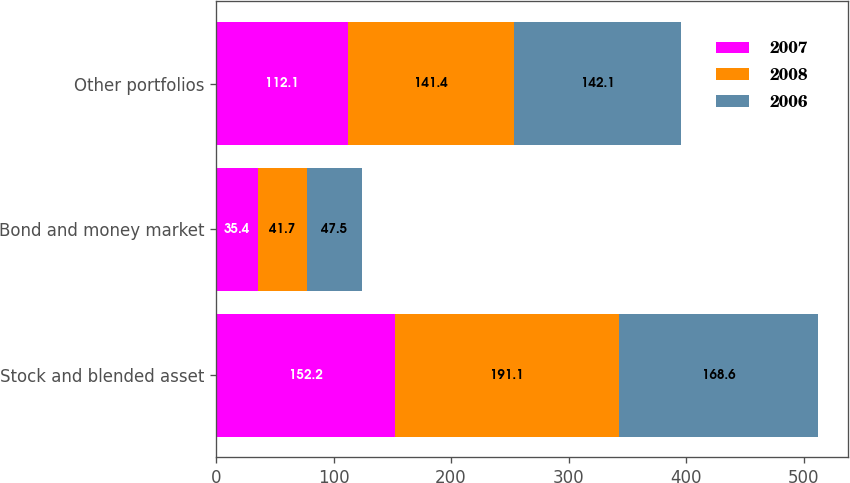<chart> <loc_0><loc_0><loc_500><loc_500><stacked_bar_chart><ecel><fcel>Stock and blended asset<fcel>Bond and money market<fcel>Other portfolios<nl><fcel>2007<fcel>152.2<fcel>35.4<fcel>112.1<nl><fcel>2008<fcel>191.1<fcel>41.7<fcel>141.4<nl><fcel>2006<fcel>168.6<fcel>47.5<fcel>142.1<nl></chart> 